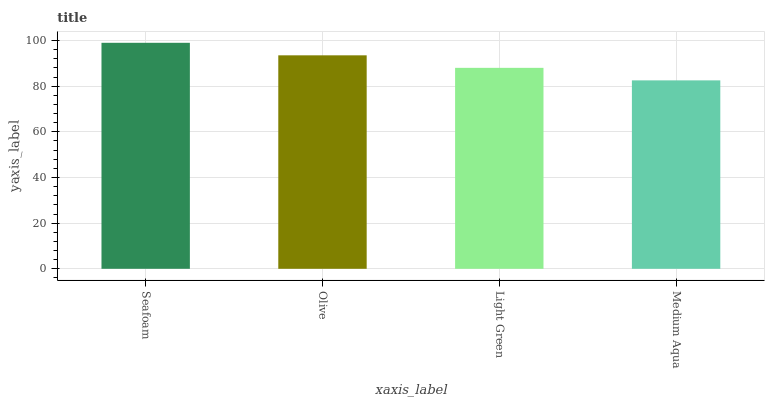Is Medium Aqua the minimum?
Answer yes or no. Yes. Is Seafoam the maximum?
Answer yes or no. Yes. Is Olive the minimum?
Answer yes or no. No. Is Olive the maximum?
Answer yes or no. No. Is Seafoam greater than Olive?
Answer yes or no. Yes. Is Olive less than Seafoam?
Answer yes or no. Yes. Is Olive greater than Seafoam?
Answer yes or no. No. Is Seafoam less than Olive?
Answer yes or no. No. Is Olive the high median?
Answer yes or no. Yes. Is Light Green the low median?
Answer yes or no. Yes. Is Medium Aqua the high median?
Answer yes or no. No. Is Olive the low median?
Answer yes or no. No. 